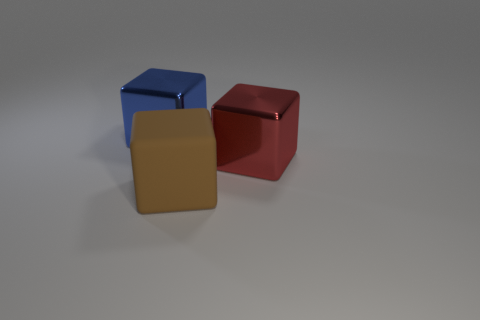How many red things are either big shiny blocks or matte objects?
Offer a very short reply. 1. There is a thing that is in front of the block that is on the right side of the large rubber object; what is its material?
Provide a short and direct response. Rubber. Is the big red object the same shape as the blue metallic thing?
Keep it short and to the point. Yes. There is another metallic thing that is the same size as the blue shiny thing; what color is it?
Offer a very short reply. Red. Is there a tiny yellow thing?
Your response must be concise. No. Does the brown cube that is in front of the blue metal block have the same material as the big red block?
Ensure brevity in your answer.  No. How many brown rubber blocks have the same size as the blue metallic block?
Offer a very short reply. 1. Are there the same number of big blue metal things in front of the blue block and blue things?
Ensure brevity in your answer.  No. How many large metal blocks are both on the left side of the brown block and on the right side of the blue thing?
Make the answer very short. 0. There is a object that is the same material as the large blue cube; what size is it?
Keep it short and to the point. Large. 